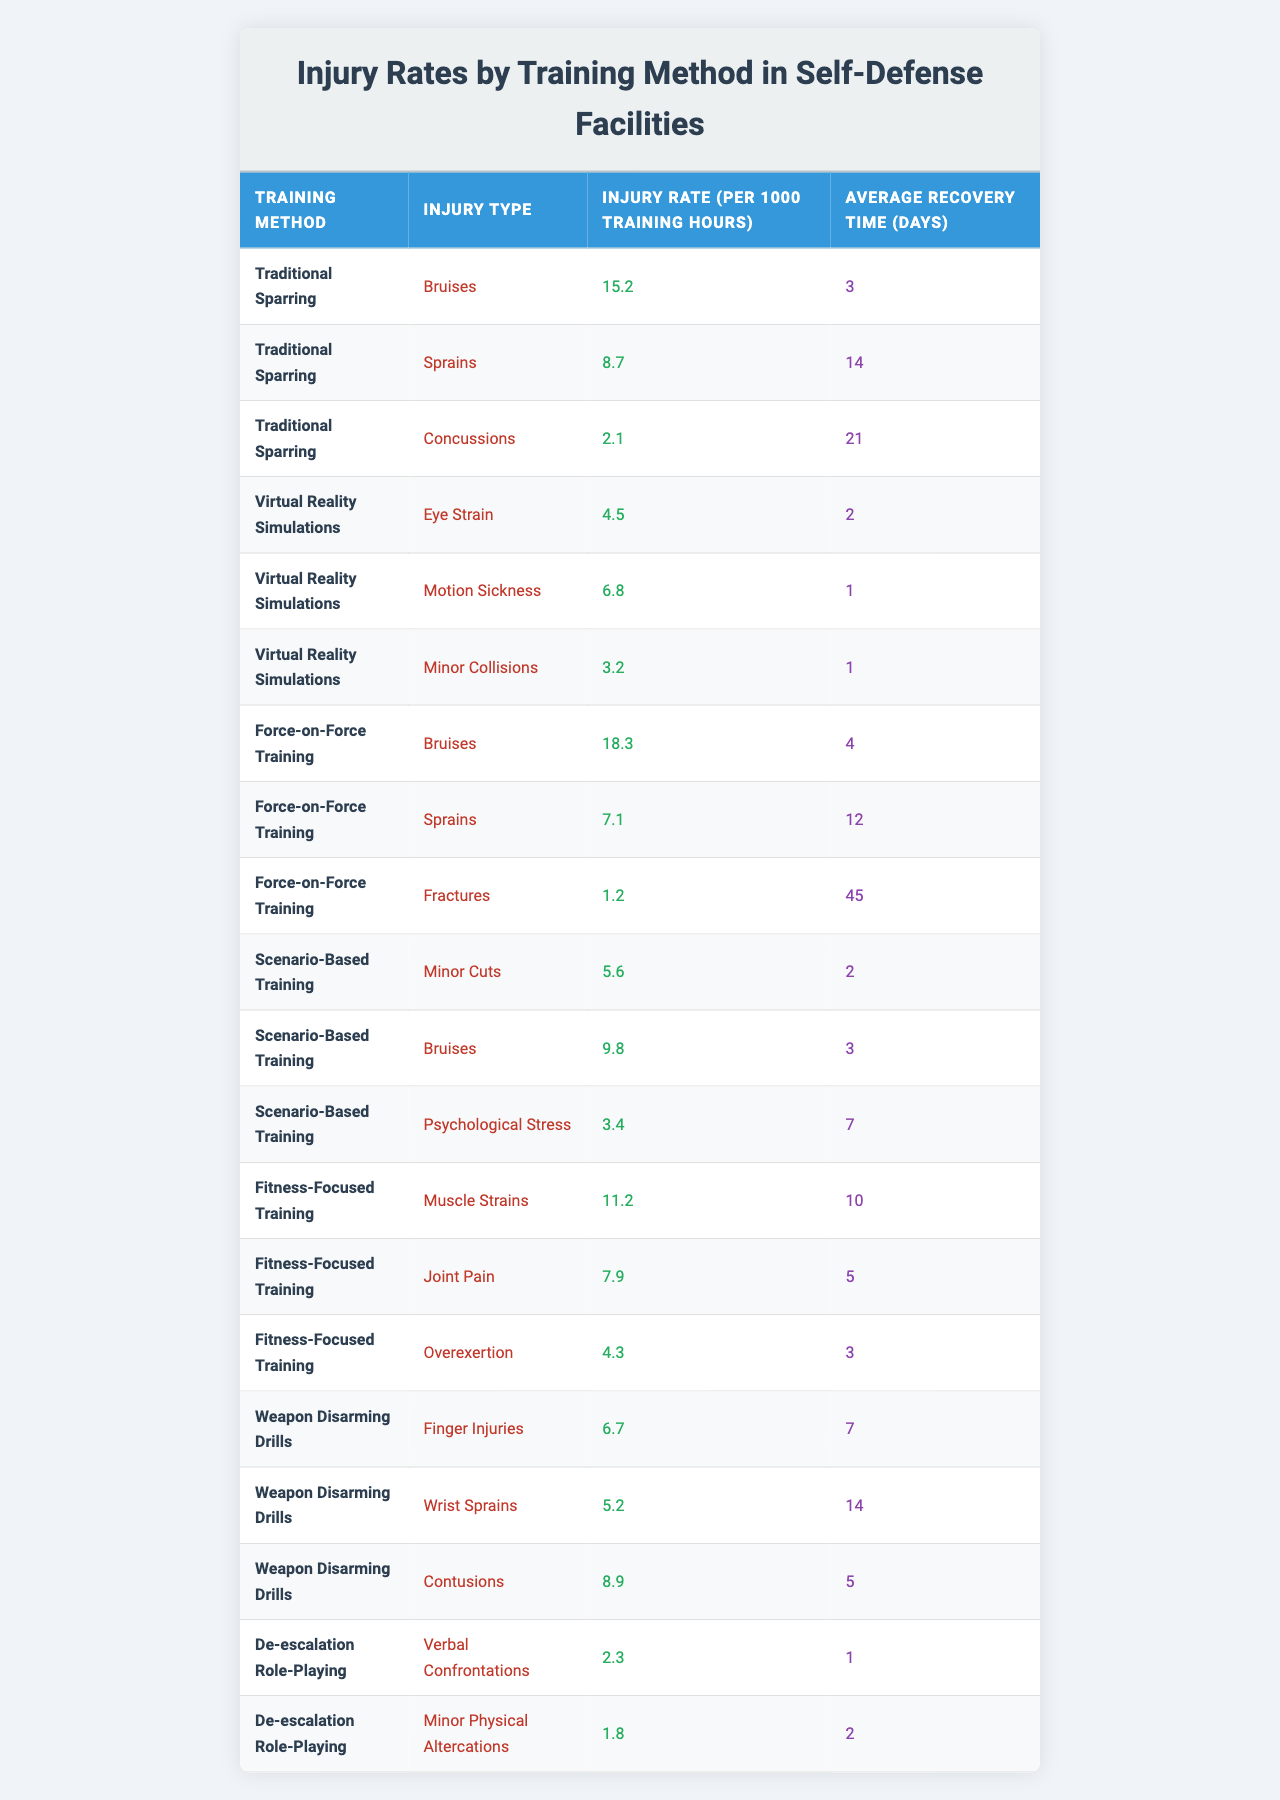What is the injury rate for bruises in Traditional Sparring? The table shows that the injury rate for bruises in Traditional Sparring is listed under the corresponding row. According to the data, it is 15.2 injuries per 1000 training hours.
Answer: 15.2 Which training method has the highest injury rate for sprains? Looking at the table, the injury rate for sprains is compared across different training methods. Traditional Sparring has an injury rate of 8.7, while Force-on-Force Training has a rate of 7.1. Therefore, Traditional Sparring has the highest rate for sprains.
Answer: Traditional Sparring What is the average recovery time for injuries sustained during Virtual Reality Simulations? The table lists the average recovery times for various injuries under Virtual Reality Simulations. The average times are: Eye Strain (2 days), Motion Sickness (1 day), and Minor Collisions (1 day). By averaging these values, we find (2 + 1 + 1) / 3 = 1.33 days.
Answer: 1.33 days Is the injury rate for fractures in Force-on-Force Training lower than the injury rate for concussions in Traditional Sparring? The table shows that the injury rate for fractures in Force-on-Force Training is 1.2 per 1000 training hours, while the injury rate for concussions in Traditional Sparring is 2.1. Since 1.2 is less than 2.1, the statement is true.
Answer: Yes What is the total injury rate for bruises across all training methods? To find the total injury rate for bruises, we sum the injury rates for bruises listed in the table: Traditional Sparring (15.2) + Force-on-Force Training (18.3) + Scenario-Based Training (9.8) = 43.3.
Answer: 43.3 Which type of training has the lowest average recovery time, and what is that time? The table lists recovery times for various training methods. Comparing them, we see that the lowest recovery times for different injury types in Virtual Reality Simulations (Eye Strain = 2 days, Motion Sickness = 1 day, Minor Collisions = 1 day) are both 1 day. Therefore, Virtual Reality Simulations have the lowest recovery time of 1 day.
Answer: 1 day Is it true that De-escalation Role-Playing has no serious injuries listed with long recovery times? By checking the injury types under De-escalation Role-Playing, we see that it mentions Verbal Confrontations (1 day) and Minor Physical Altercations (2 days), both of which are short recovery times and are not classified as serious injuries. Thus, the statement is true.
Answer: Yes How does the injury rate for overexertion in Fitness-Focused Training compare to the injury rate for minor collisions in Virtual Reality Simulations? According to the table, the injury rate for overexertion in Fitness-Focused Training is 4.3, whereas the injury rate for minor collisions in Virtual Reality Simulations is 3.2. Since 4.3 is greater than 3.2, Fitness-Focused Training has a higher injury rate for overexertion.
Answer: Higher What is the average injury rate across all training methods for sprains? The injury rates for sprains are Traditional Sparring (8.7) and Force-on-Force Training (7.1), which totals 15.8. Dividing this by the number of methods (2) gives an average of 15.8 / 2 = 7.9.
Answer: 7.9 Which training method has the highest possibility of injury recovery in less than 3 days? From the table, we look at average recovery times under each method. The injuries in Virtual Reality Simulations (1 and 2 days) and De-escalation Role-Playing (1 and 2 days) recover in less than 3 days. However, the rate for Virtual Reality Simulations shows more types of injuries with shorter recovery times. Hence it is the best.
Answer: Virtual Reality Simulations 